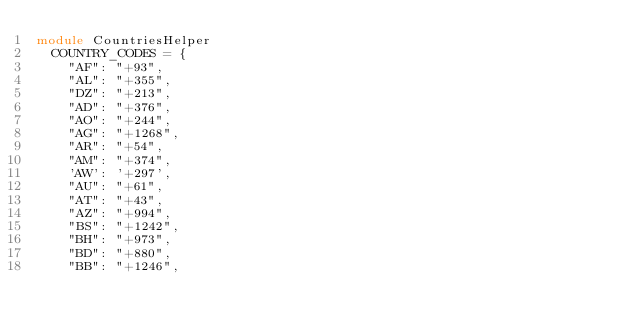Convert code to text. <code><loc_0><loc_0><loc_500><loc_500><_Ruby_>module CountriesHelper
  COUNTRY_CODES = {
    "AF": "+93",
    "AL": "+355",
    "DZ": "+213",
    "AD": "+376",
    "AO": "+244",
    "AG": "+1268",
    "AR": "+54",
    "AM": "+374",
    'AW': '+297',
    "AU": "+61",
    "AT": "+43",
    "AZ": "+994",
    "BS": "+1242",
    "BH": "+973",
    "BD": "+880",
    "BB": "+1246",</code> 